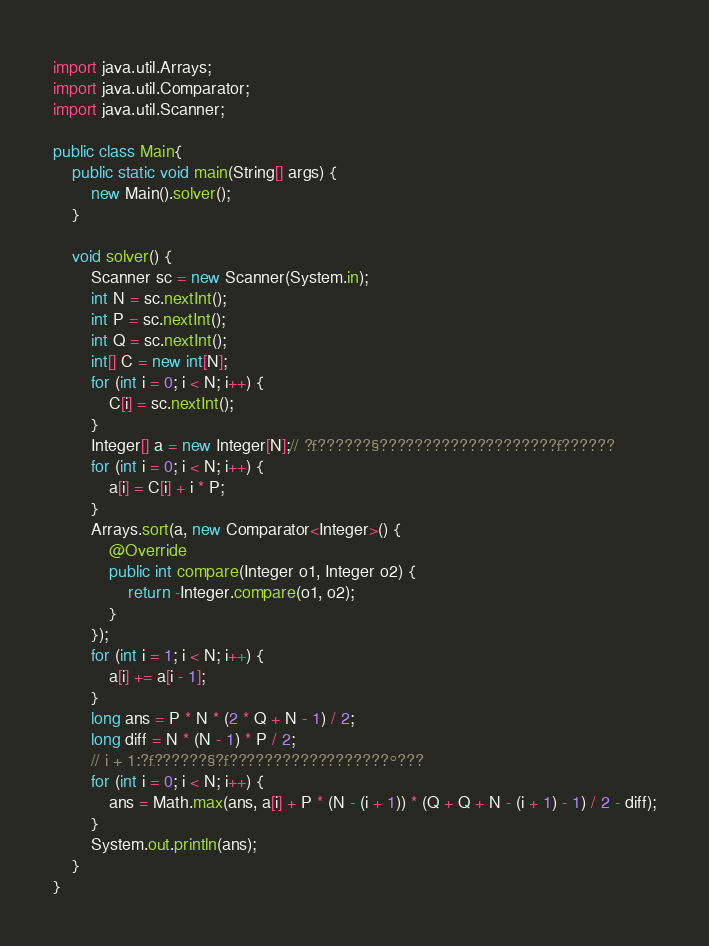Convert code to text. <code><loc_0><loc_0><loc_500><loc_500><_Java_>import java.util.Arrays;
import java.util.Comparator;
import java.util.Scanner;

public class Main{
	public static void main(String[] args) {
		new Main().solver();
	}

	void solver() {
		Scanner sc = new Scanner(System.in);
		int N = sc.nextInt();
		int P = sc.nextInt();
		int Q = sc.nextInt();
		int[] C = new int[N];
		for (int i = 0; i < N; i++) {
			C[i] = sc.nextInt();
		}
		Integer[] a = new Integer[N];// ?£??????§????????????????????£??????
		for (int i = 0; i < N; i++) {
			a[i] = C[i] + i * P;
		}
		Arrays.sort(a, new Comparator<Integer>() {
			@Override
			public int compare(Integer o1, Integer o2) {
				return -Integer.compare(o1, o2);
			}
		});
		for (int i = 1; i < N; i++) {
			a[i] += a[i - 1];
		}
		long ans = P * N * (2 * Q + N - 1) / 2;
		long diff = N * (N - 1) * P / 2;
		// i + 1:?£??????§?£??????????????????°???
		for (int i = 0; i < N; i++) {
			ans = Math.max(ans, a[i] + P * (N - (i + 1)) * (Q + Q + N - (i + 1) - 1) / 2 - diff);
		}
		System.out.println(ans);
	}
}</code> 